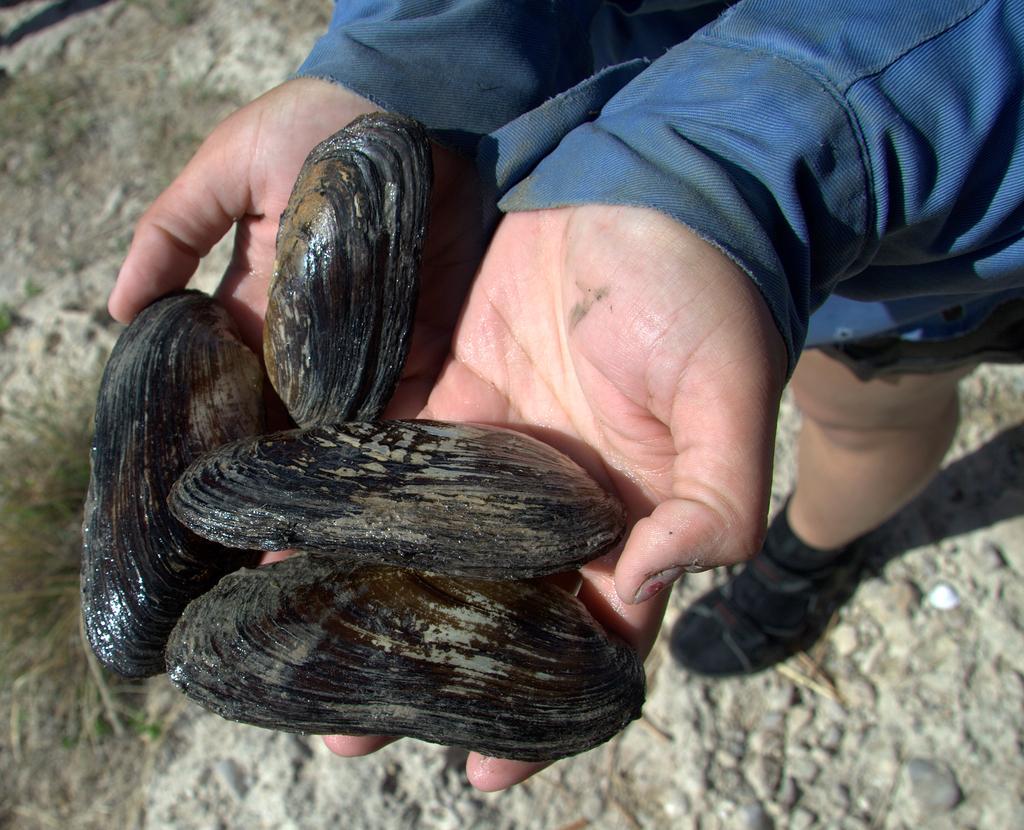How would you summarize this image in a sentence or two? In this picture, it seems like shells on hands in the foreground. 